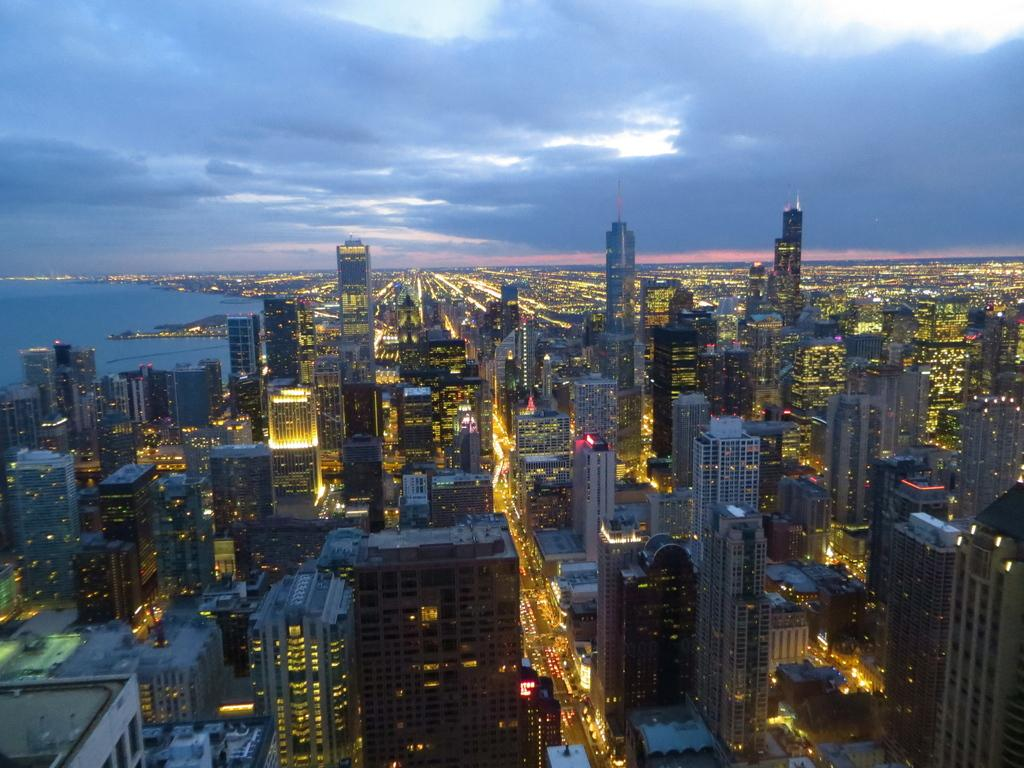What type of structures are located at the bottom of the image? There are buildings at the bottom of the image. What else can be seen at the bottom of the image? There are lights and a road visible at the bottom of the image. What is visible at the top of the image? Water and the sky are visible at the top of the image. What can be observed in the sky at the top of the image? There are clouds in the sky at the top of the image. Where is the frog sitting in the image? There is no frog present in the image. What type of lamp is illuminating the road in the image? There is no lamp present in the image; the lights mentioned are not specified as lamps. 